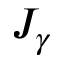Convert formula to latex. <formula><loc_0><loc_0><loc_500><loc_500>J _ { \gamma }</formula> 